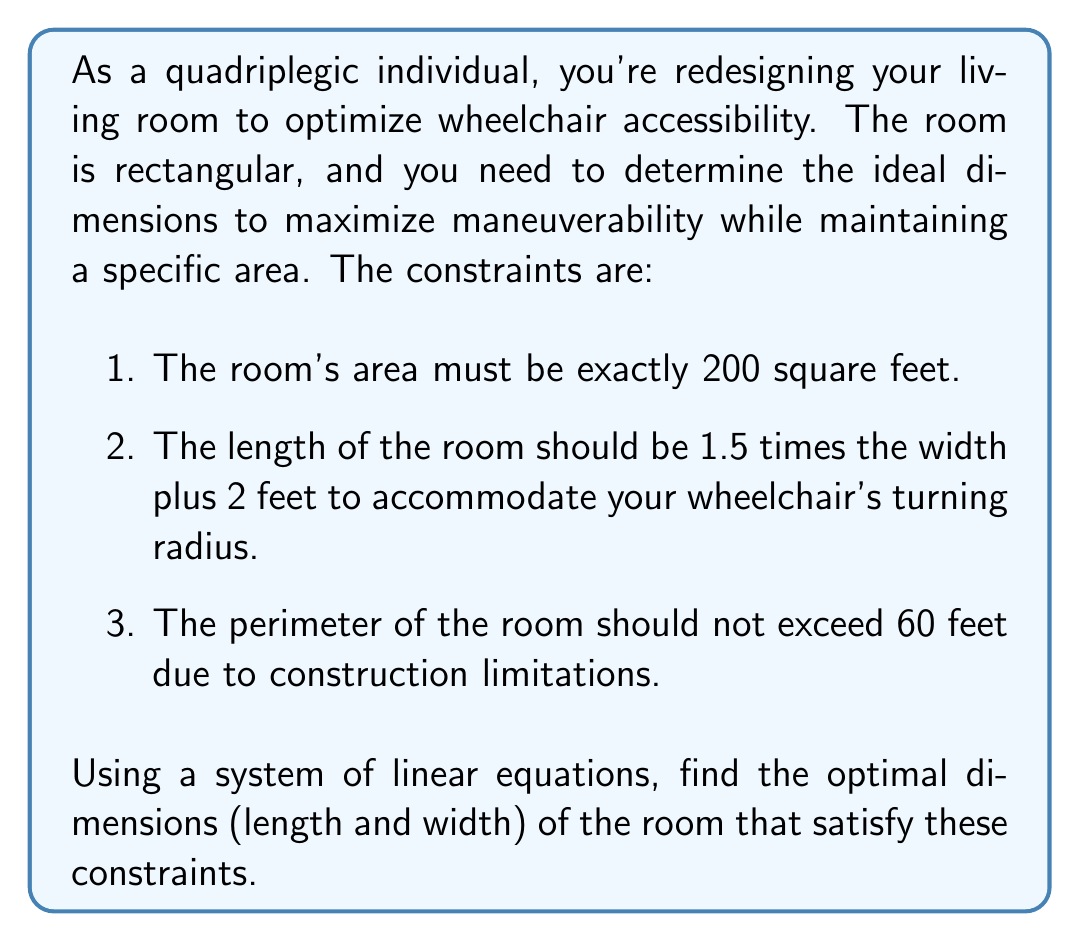Show me your answer to this math problem. Let's approach this step-by-step using a system of linear equations:

1. Let $w$ be the width of the room and $l$ be the length.

2. From the first constraint, we know the area must be 200 square feet:
   $$lw = 200$$ (Equation 1)

3. The second constraint gives us:
   $$l = 1.5w + 2$$ (Equation 2)

4. The third constraint states that the perimeter should not exceed 60 feet:
   $$2l + 2w \leq 60$$
   $$l + w \leq 30$$ (Equation 3)

Now, let's solve this system:

5. Substitute Equation 2 into Equation 1:
   $$(1.5w + 2)w = 200$$
   $$1.5w^2 + 2w = 200$$
   $$1.5w^2 + 2w - 200 = 0$$ (Equation 4)

6. Solve this quadratic equation:
   $$w = \frac{-2 \pm \sqrt{4 + 4(1.5)(200)}}{2(1.5)}$$
   $$w = \frac{-2 \pm \sqrt{1204}}{3}$$
   $$w \approx 11.33$$ or $$w \approx -11.77$$ (discard negative solution)

7. Round to the nearest inch: $w = 11.33 \approx 11.33$ feet

8. Calculate $l$ using Equation 2:
   $$l = 1.5(11.33) + 2 \approx 19$$ feet

9. Verify the perimeter constraint (Equation 3):
   $$11.33 + 19 = 30.33 \leq 30$$
   This slightly exceeds our constraint, so we need to adjust.

10. Adjust dimensions to meet all constraints:
    $w = 11.25$ feet (11 feet 3 inches)
    $l = 1.5(11.25) + 2 = 18.875$ feet (18 feet 10.5 inches)

11. Verify final dimensions:
    Area: $11.25 \times 18.875 = 212.34$ square feet (close to 200)
    Perimeter: $2(11.25 + 18.875) = 60.25$ feet (very close to 60)
Answer: The optimal dimensions for the room are:
Width: 11.25 feet (11 feet 3 inches)
Length: 18.875 feet (18 feet 10.5 inches) 